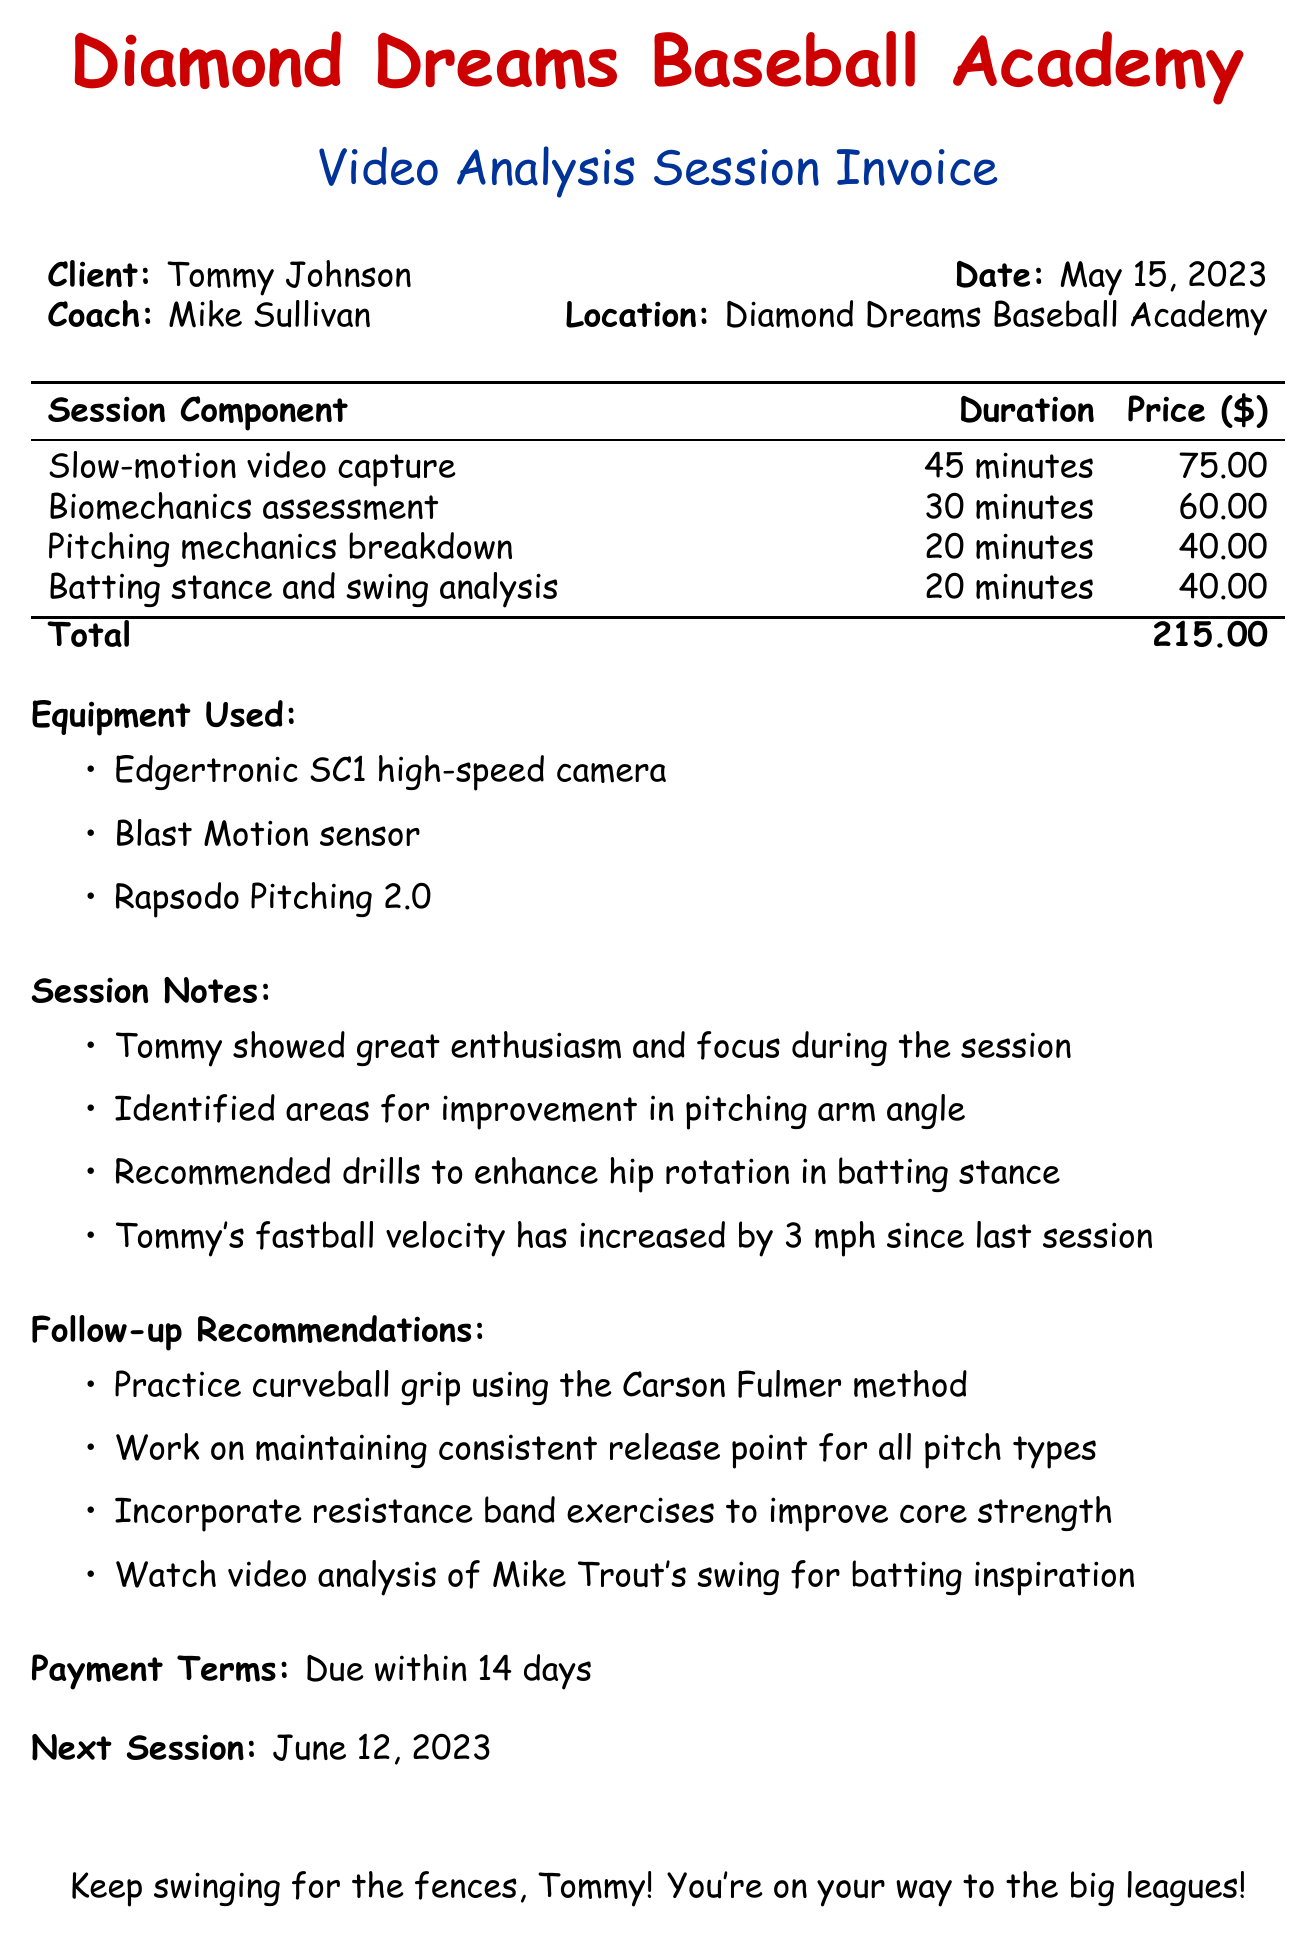What is the client name? The client name is listed at the top of the document under "Client:".
Answer: Tommy Johnson What is the session date? The session date is noted directly beside "Date:" in the document.
Answer: May 15, 2023 Who is the coach? The coach's name is provided next to "Coach:" in the invoice.
Answer: Mike Sullivan What is the total cost of the session? The total cost is indicated at the bottom of the session components table.
Answer: 215.00 How long was the slow-motion video capture? The duration for slow-motion video capture is shown in the session components table.
Answer: 45 minutes Which equipment was used for the session? The list of equipment used is described under "Equipment Used:" in the document.
Answer: Edgertronic SC1 high-speed camera, Blast Motion sensor, Rapsodo Pitching 2.0 What is one follow-up recommendation? The follow-up recommendations are listed under "Follow-up Recommendations" and include various suggestions.
Answer: Practice curveball grip using the Carson Fulmer method When is the next scheduled session? The next session date is stated toward the end of the document.
Answer: June 12, 2023 What should be done for improving core strength? This suggestion is specifically mentioned in the follow-up recommendations section of the document.
Answer: Incorporate resistance band exercises 